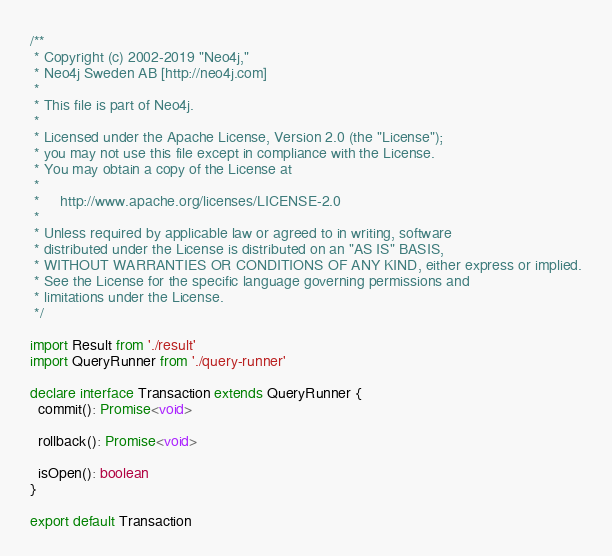Convert code to text. <code><loc_0><loc_0><loc_500><loc_500><_TypeScript_>/**
 * Copyright (c) 2002-2019 "Neo4j,"
 * Neo4j Sweden AB [http://neo4j.com]
 *
 * This file is part of Neo4j.
 *
 * Licensed under the Apache License, Version 2.0 (the "License");
 * you may not use this file except in compliance with the License.
 * You may obtain a copy of the License at
 *
 *     http://www.apache.org/licenses/LICENSE-2.0
 *
 * Unless required by applicable law or agreed to in writing, software
 * distributed under the License is distributed on an "AS IS" BASIS,
 * WITHOUT WARRANTIES OR CONDITIONS OF ANY KIND, either express or implied.
 * See the License for the specific language governing permissions and
 * limitations under the License.
 */

import Result from './result'
import QueryRunner from './query-runner'

declare interface Transaction extends QueryRunner {
  commit(): Promise<void>

  rollback(): Promise<void>

  isOpen(): boolean
}

export default Transaction
</code> 